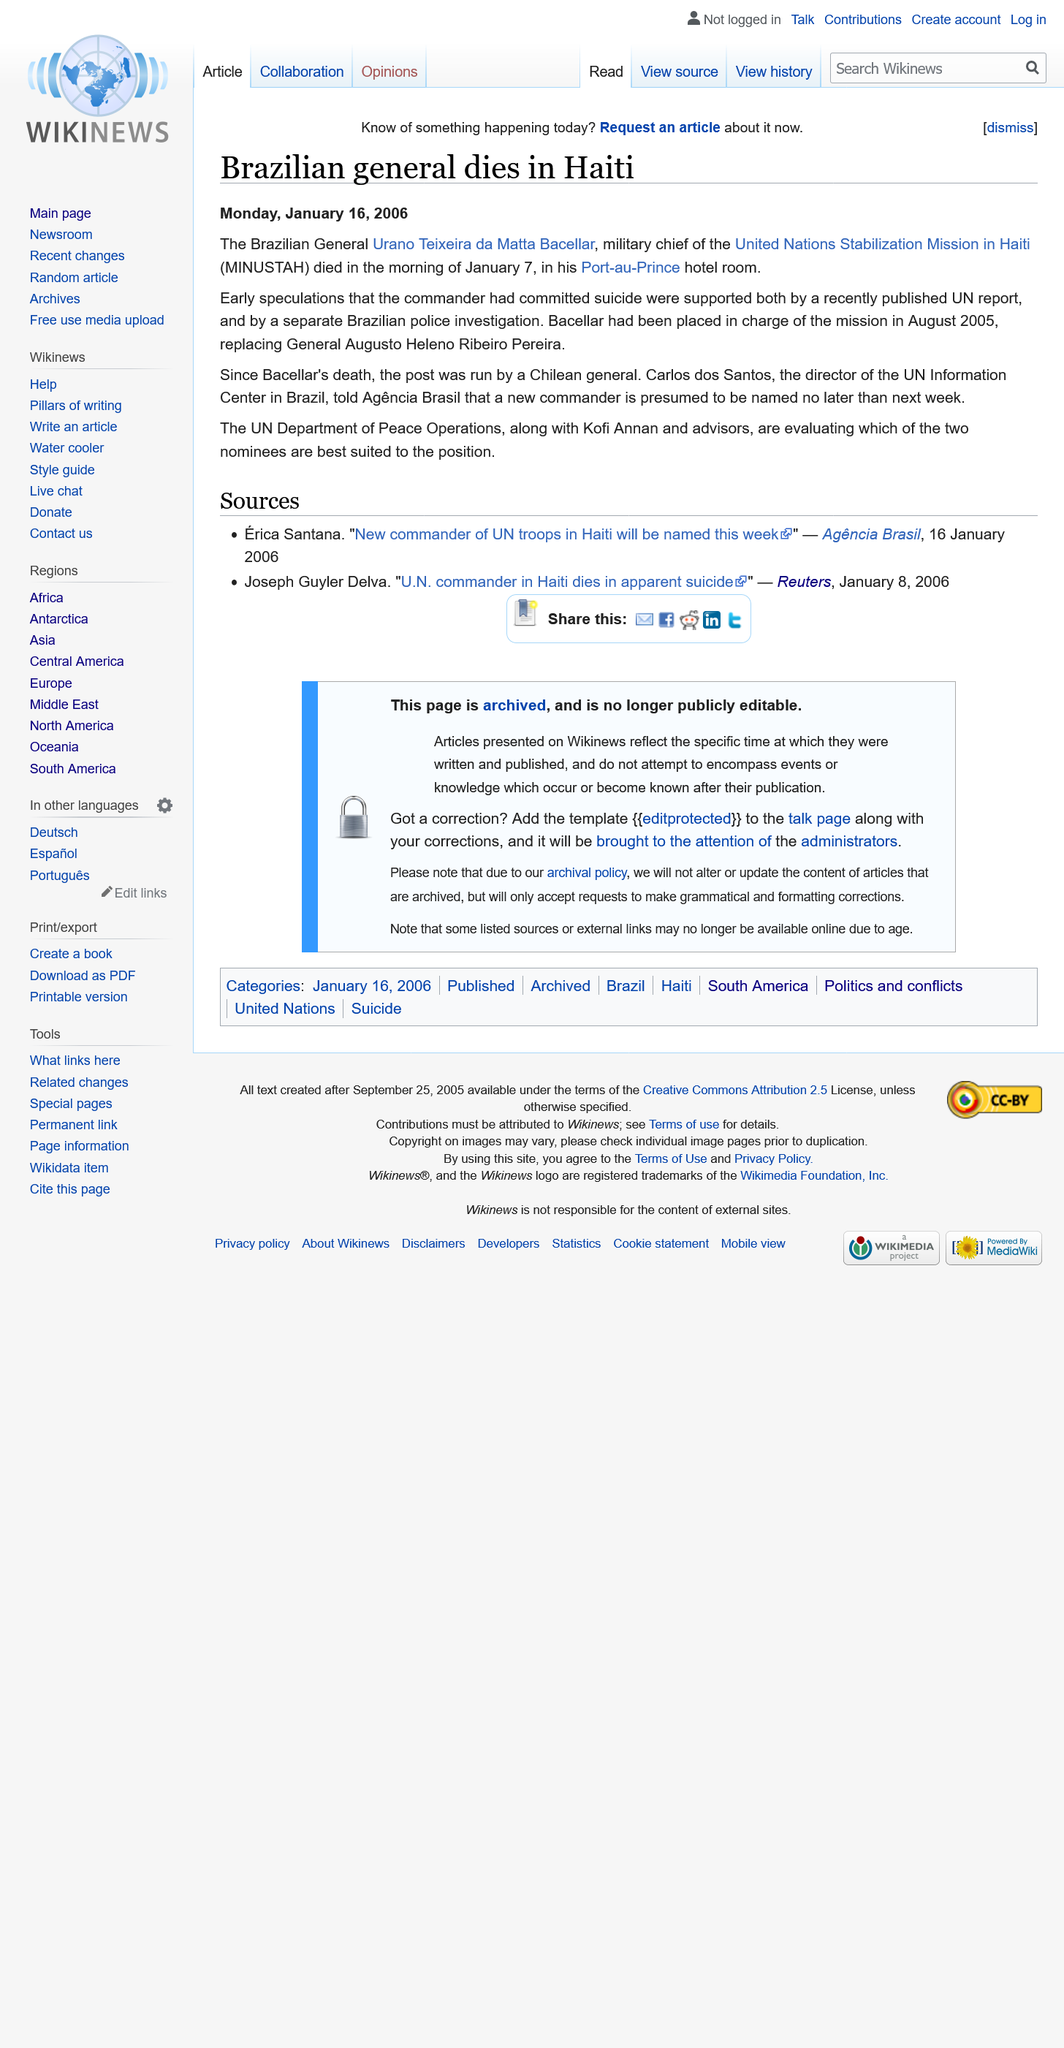Draw attention to some important aspects in this diagram. When was Bacellar placed in charge of the mission? August 2005. Since the death of Bacellar, the post was run by the Chilean General. The article titled "Brazilian general dies in Haiti" was published on January 16th 2006. 